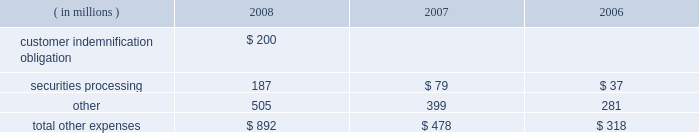Note 21 .
Expenses during the fourth quarter of 2008 , we elected to provide support to certain investment accounts managed by ssga through the purchase of asset- and mortgage-backed securities and a cash infusion , which resulted in a charge of $ 450 million .
Ssga manages certain investment accounts , offered to retirement plans , that allow participants to purchase and redeem units at a constant net asset value regardless of volatility in the underlying value of the assets held by the account .
The accounts enter into contractual arrangements with independent third-party financial institutions that agree to make up any shortfall in the account if all the units are redeemed at the constant net asset value .
The financial institutions have the right , under certain circumstances , to terminate this guarantee with respect to future investments in the account .
During 2008 , the liquidity and pricing issues in the fixed-income markets adversely affected the market value of the securities in these accounts to the point that the third-party guarantors considered terminating their financial guarantees with the accounts .
Although we were not statutorily or contractually obligated to do so , we elected to purchase approximately $ 2.49 billion of asset- and mortgage-backed securities from these accounts that had been identified as presenting increased risk in the current market environment and to contribute an aggregate of $ 450 million to the accounts to improve the ratio of the market value of the accounts 2019 portfolio holdings to the book value of the accounts .
We have no ongoing commitment or intent to provide support to these accounts .
The securities are carried in investment securities available for sale in our consolidated statement of condition .
The components of other expenses were as follows for the years ended december 31: .
In september and october 2008 , lehman brothers holdings inc. , or lehman brothers , and certain of its affiliates filed for bankruptcy or other insolvency proceedings .
While we had no unsecured financial exposure to lehman brothers or its affiliates , we indemnified certain customers in connection with these and other collateralized repurchase agreements with lehman brothers entities .
In the then current market environment , the market value of the underlying collateral had declined .
During the third quarter of 2008 , to the extent these declines resulted in collateral value falling below the indemnification obligation , we recorded a reserve to provide for our estimated net exposure .
The reserve , which totaled $ 200 million , was based on the cost of satisfying the indemnification obligation net of the fair value of the collateral , which we purchased during the fourth quarter of 2008 .
The collateral , composed of commercial real estate loans which are discussed in note 5 , is recorded in loans and leases in our consolidated statement of condition. .
What portion of the total other expenses is related to customer indemnification obligation in 2008? 
Computations: (200 / 892)
Answer: 0.22422. 